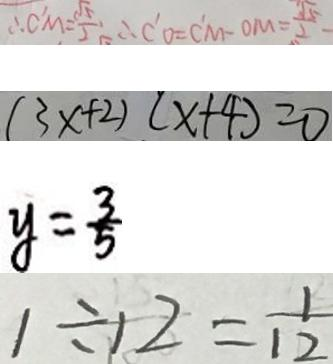Convert formula to latex. <formula><loc_0><loc_0><loc_500><loc_500>\therefore C ^ { \prime } M = \frac { \sqrt { 5 } } { 2 } \therefore C ^ { \prime } O = C ^ { \prime } M - O M = \frac { \sqrt { 5 } } { 2 } 
 ( 3 x + 2 ) ( x + 4 ) = 0 
 y = \frac { 3 } { 5 } 
 1 \div 1 2 = \frac { 1 } { 1 2 }</formula> 